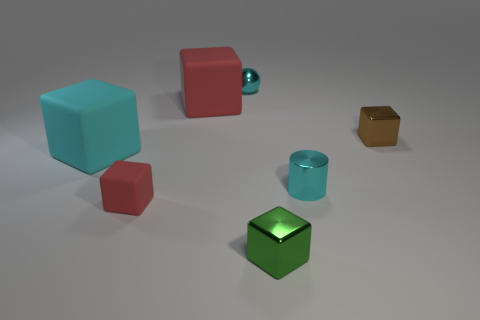Add 2 small cyan cylinders. How many objects exist? 9 Subtract 0 green spheres. How many objects are left? 7 Subtract all cylinders. How many objects are left? 6 Subtract 3 cubes. How many cubes are left? 2 Subtract all purple spheres. Subtract all yellow cylinders. How many spheres are left? 1 Subtract all brown blocks. How many yellow cylinders are left? 0 Subtract all small metallic cylinders. Subtract all small cylinders. How many objects are left? 5 Add 4 cyan rubber blocks. How many cyan rubber blocks are left? 5 Add 6 blue metal spheres. How many blue metal spheres exist? 6 Subtract all cyan blocks. How many blocks are left? 4 